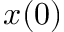Convert formula to latex. <formula><loc_0><loc_0><loc_500><loc_500>x ( 0 )</formula> 